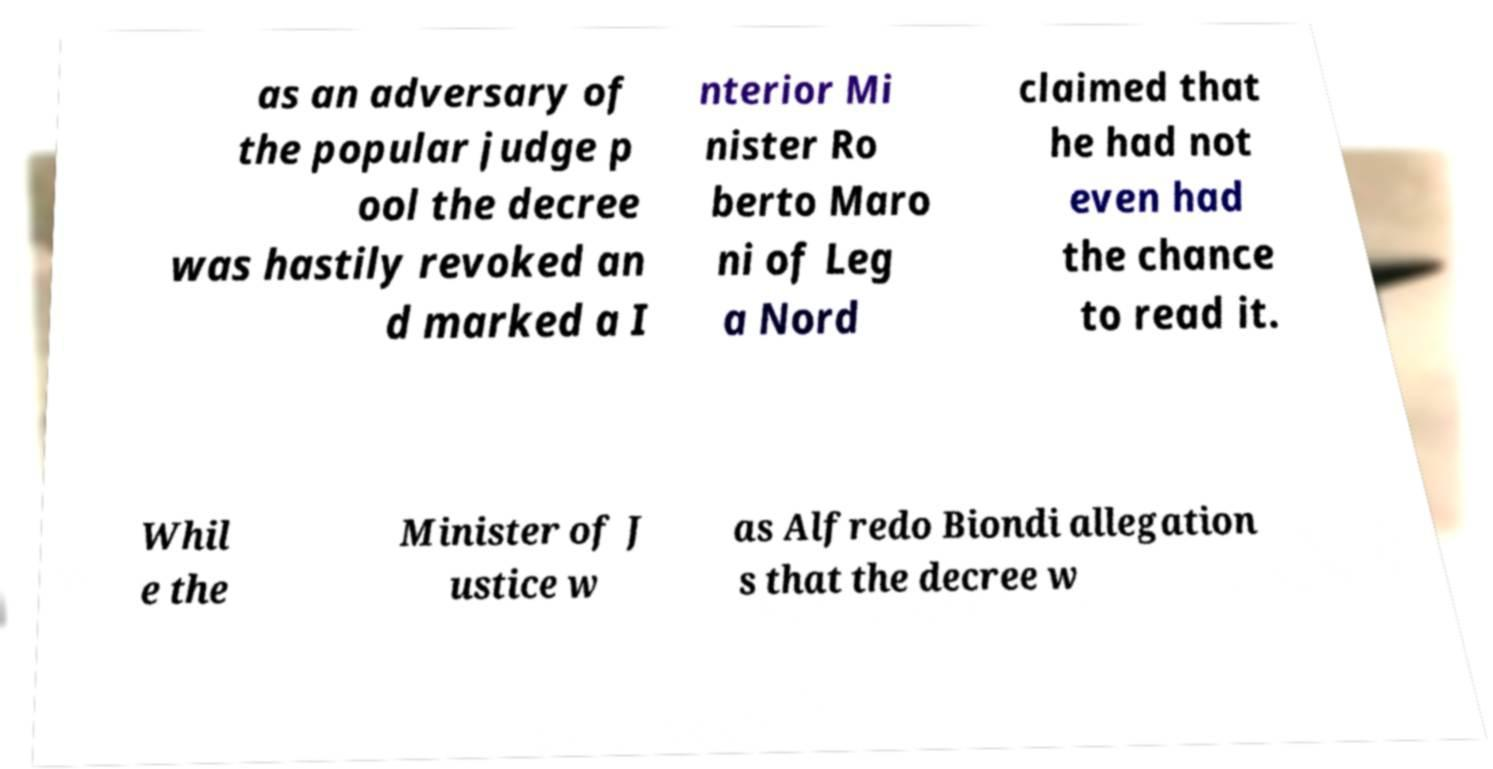Could you extract and type out the text from this image? as an adversary of the popular judge p ool the decree was hastily revoked an d marked a I nterior Mi nister Ro berto Maro ni of Leg a Nord claimed that he had not even had the chance to read it. Whil e the Minister of J ustice w as Alfredo Biondi allegation s that the decree w 